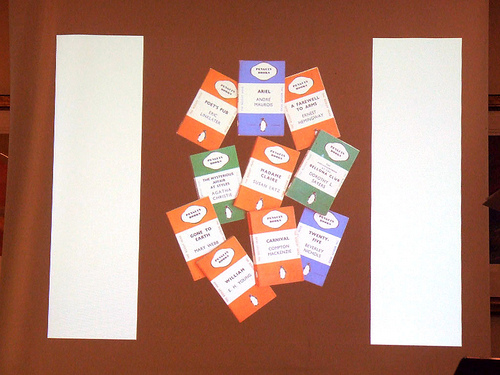<image>
Is there a card behind the card? Yes. From this viewpoint, the card is positioned behind the card, with the card partially or fully occluding the card. 